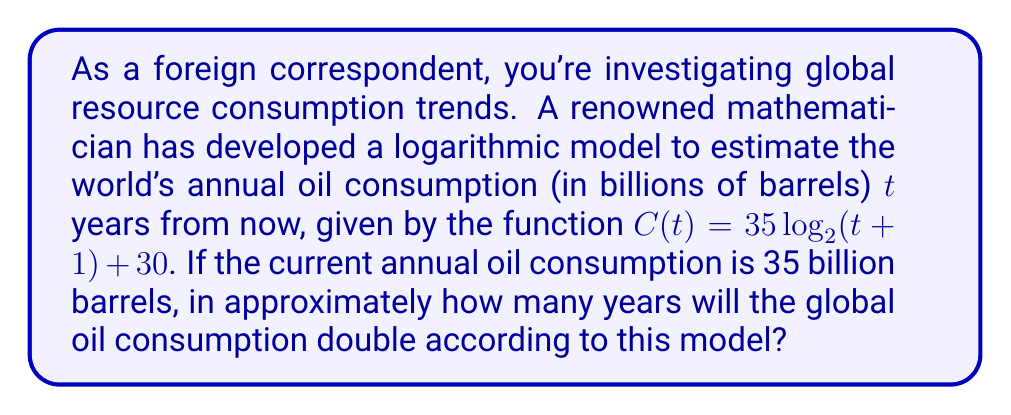Teach me how to tackle this problem. To solve this problem, we'll follow these steps:

1) First, we need to find the value of t when C(t) is double the current consumption:
   Current consumption = 35 billion barrels
   Double consumption = 70 billion barrels

2) We set up the equation:
   $70 = 35 \log_2(t+1) + 30$

3) Subtract 30 from both sides:
   $40 = 35 \log_2(t+1)$

4) Divide both sides by 35:
   $\frac{40}{35} = \log_2(t+1)$

5) Apply $2^x$ to both sides:
   $2^{\frac{40}{35}} = t+1$

6) Subtract 1 from both sides:
   $2^{\frac{40}{35}} - 1 = t$

7) Calculate the value:
   $t \approx 31.54$ years

Therefore, according to this logarithmic model, global oil consumption will approximately double in about 32 years.
Answer: Approximately 32 years 